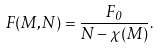<formula> <loc_0><loc_0><loc_500><loc_500>F ( M , N ) = \frac { F _ { 0 } } { N - \chi ( M ) } .</formula> 